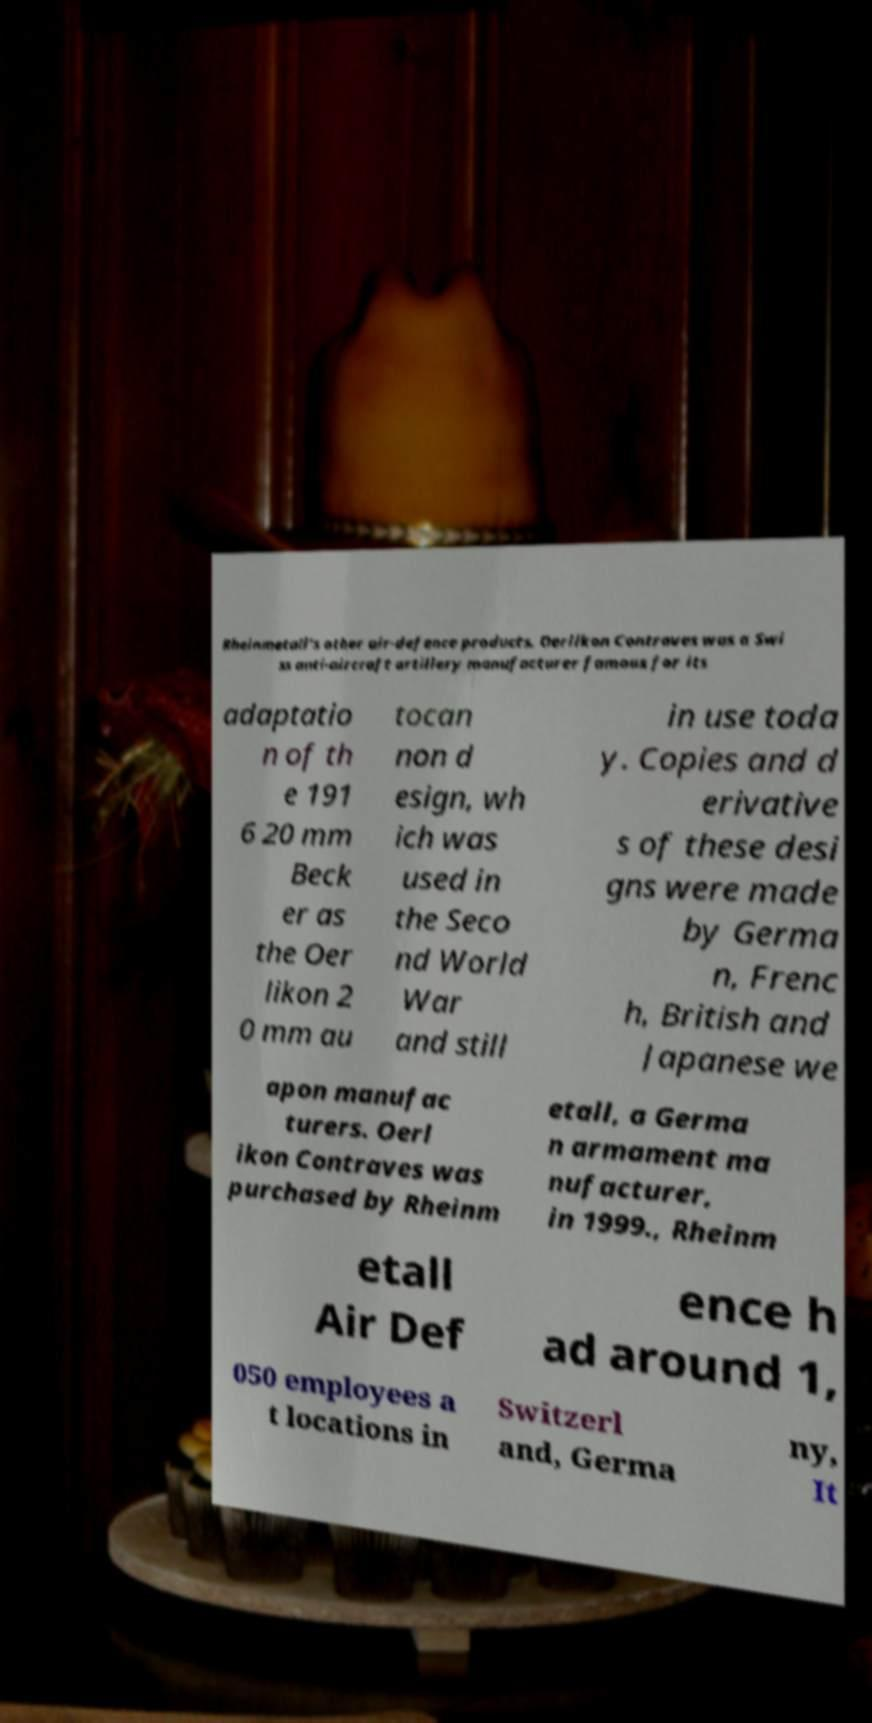I need the written content from this picture converted into text. Can you do that? Rheinmetall's other air-defence products. Oerlikon Contraves was a Swi ss anti-aircraft artillery manufacturer famous for its adaptatio n of th e 191 6 20 mm Beck er as the Oer likon 2 0 mm au tocan non d esign, wh ich was used in the Seco nd World War and still in use toda y. Copies and d erivative s of these desi gns were made by Germa n, Frenc h, British and Japanese we apon manufac turers. Oerl ikon Contraves was purchased by Rheinm etall, a Germa n armament ma nufacturer, in 1999., Rheinm etall Air Def ence h ad around 1, 050 employees a t locations in Switzerl and, Germa ny, It 